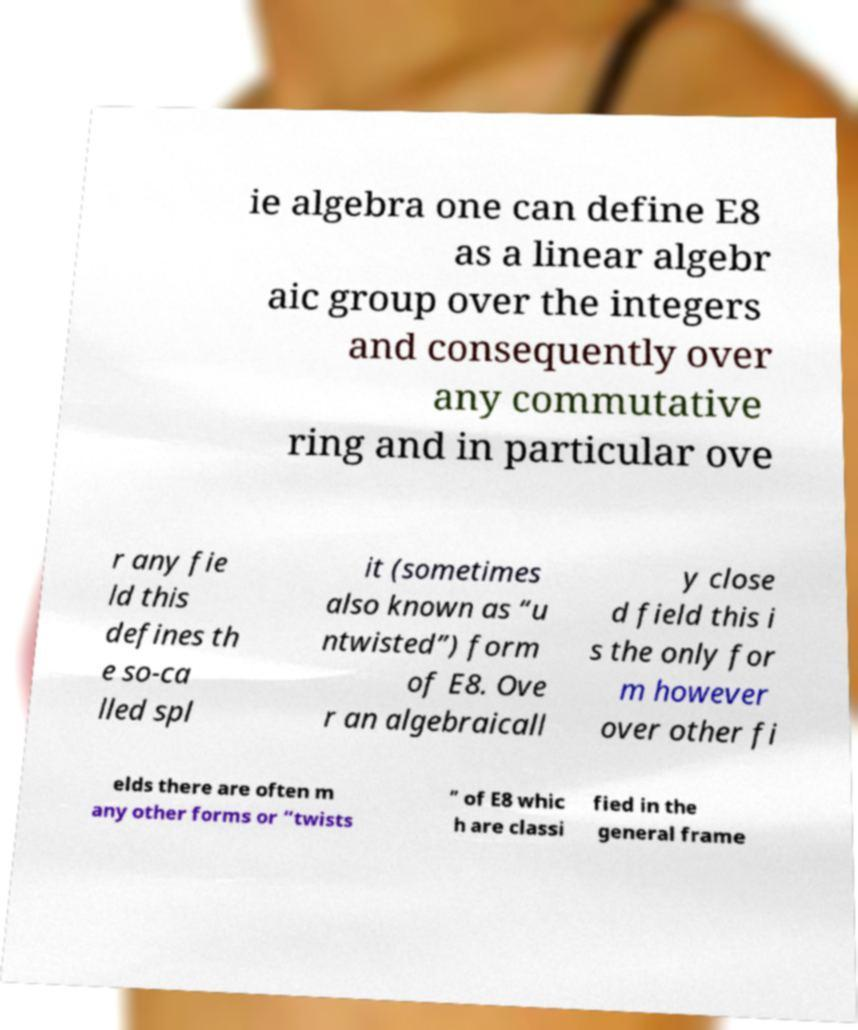For documentation purposes, I need the text within this image transcribed. Could you provide that? ie algebra one can define E8 as a linear algebr aic group over the integers and consequently over any commutative ring and in particular ove r any fie ld this defines th e so-ca lled spl it (sometimes also known as “u ntwisted”) form of E8. Ove r an algebraicall y close d field this i s the only for m however over other fi elds there are often m any other forms or “twists ” of E8 whic h are classi fied in the general frame 